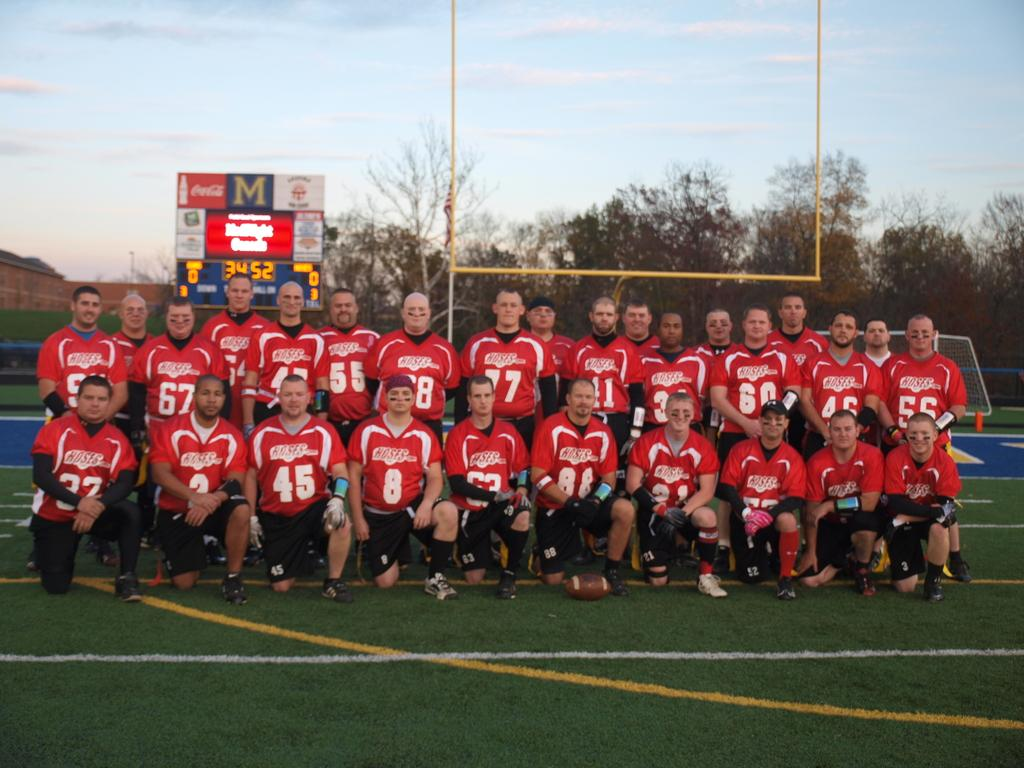<image>
Present a compact description of the photo's key features. Hoses is the name of the team on all the jerseys of this group photo. 